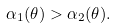Convert formula to latex. <formula><loc_0><loc_0><loc_500><loc_500>\alpha _ { 1 } ( \theta ) > \alpha _ { 2 } ( \theta ) .</formula> 